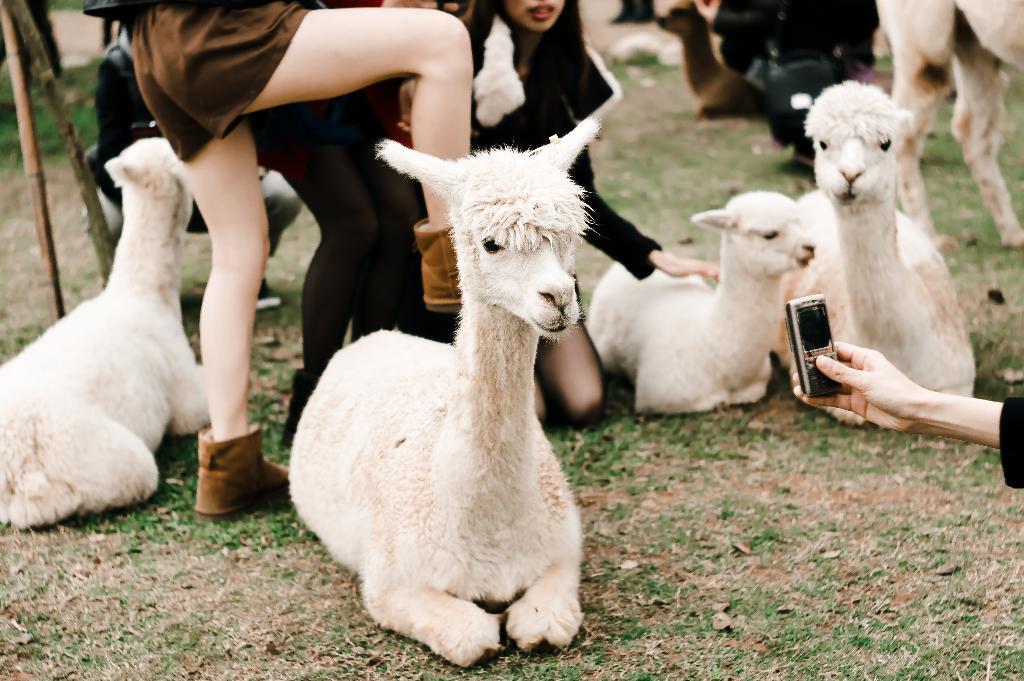How would you summarize this image in a sentence or two? In this picture we can see a phone and the hand of a person. We can see a few animals on the grass. We can see the wooden objects, boots and the legs of a person visible on the left side. There are a few people visible in the background. 